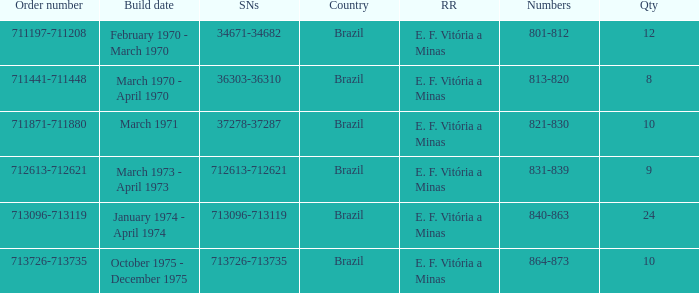How many railroads have the numbers 864-873? 1.0. 